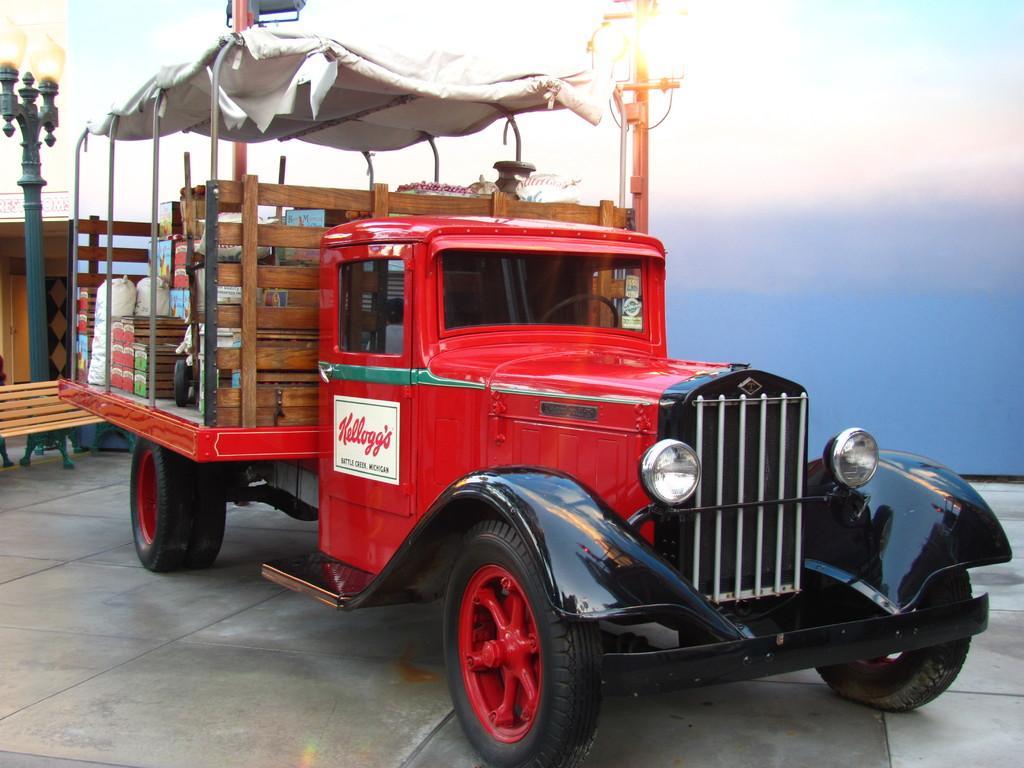Could you give a brief overview of what you see in this image? Here I can see a red color vehicle on the floor. In the background, I can see a pole, bench and a building. On the top of the image I can see the sky. 